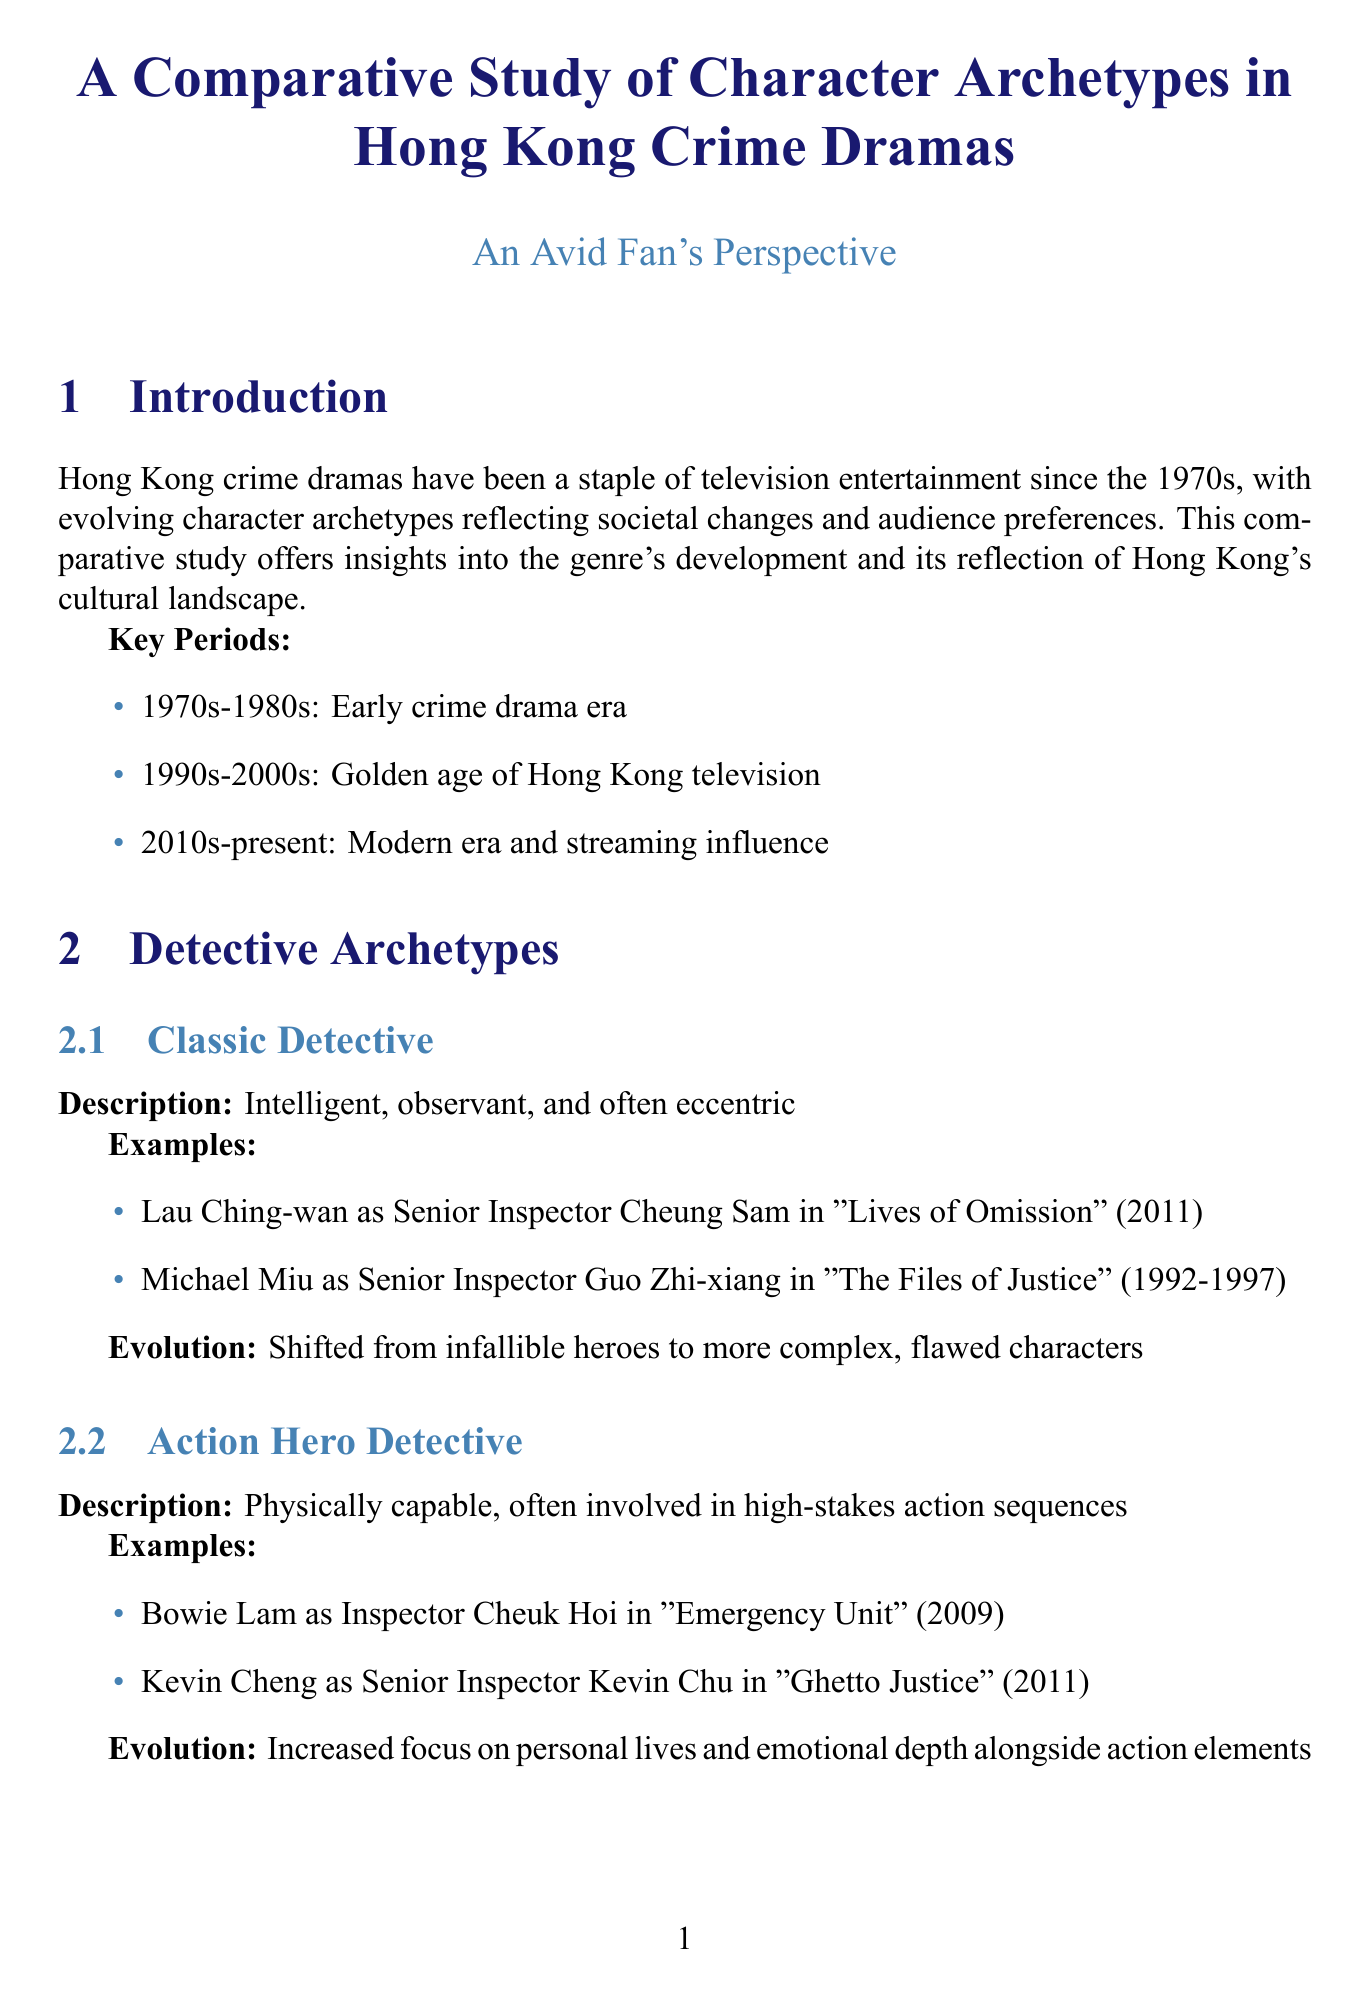What year did the early crime drama era begin? The early crime drama era in Hong Kong started in the 1970s.
Answer: 1970s Who portrayed Senior Inspector Cheung Sam? The document lists Lau Ching-wan as the actor for Senior Inspector Cheung Sam in "Lives of Omission."
Answer: Lau Ching-wan What is a key theme discussed in the thematic evolution section? The thematic evolution section mentions increased incorporation of real-world issues such as corruption and wealth inequality.
Answer: Social Commentary What type of character is described as "Operating in secret, often facing moral dilemmas"? This description pertains to the "Undercover Detective."
Answer: Undercover Detective How many notable series are mentioned in the notable series and influence section? The document lists three notable series: "Police Cadet," "Forensic Heroes," and "Line Walker."
Answer: Three What is the evolution of the triad boss character archetype? The document explains that triad bosses evolved from one-dimensional villains to complex anti-heroes.
Answer: Complex anti-heroes Which detective archetype increased focus on personal lives and emotional depth? The "Action Hero Detective" archetype has seen this increased focus.
Answer: Action Hero Detective What significant trend is noted regarding production styles? The document indicates an evolution from studio-based filming to more location shoots and cinematic aesthetics.
Answer: Visual Style 